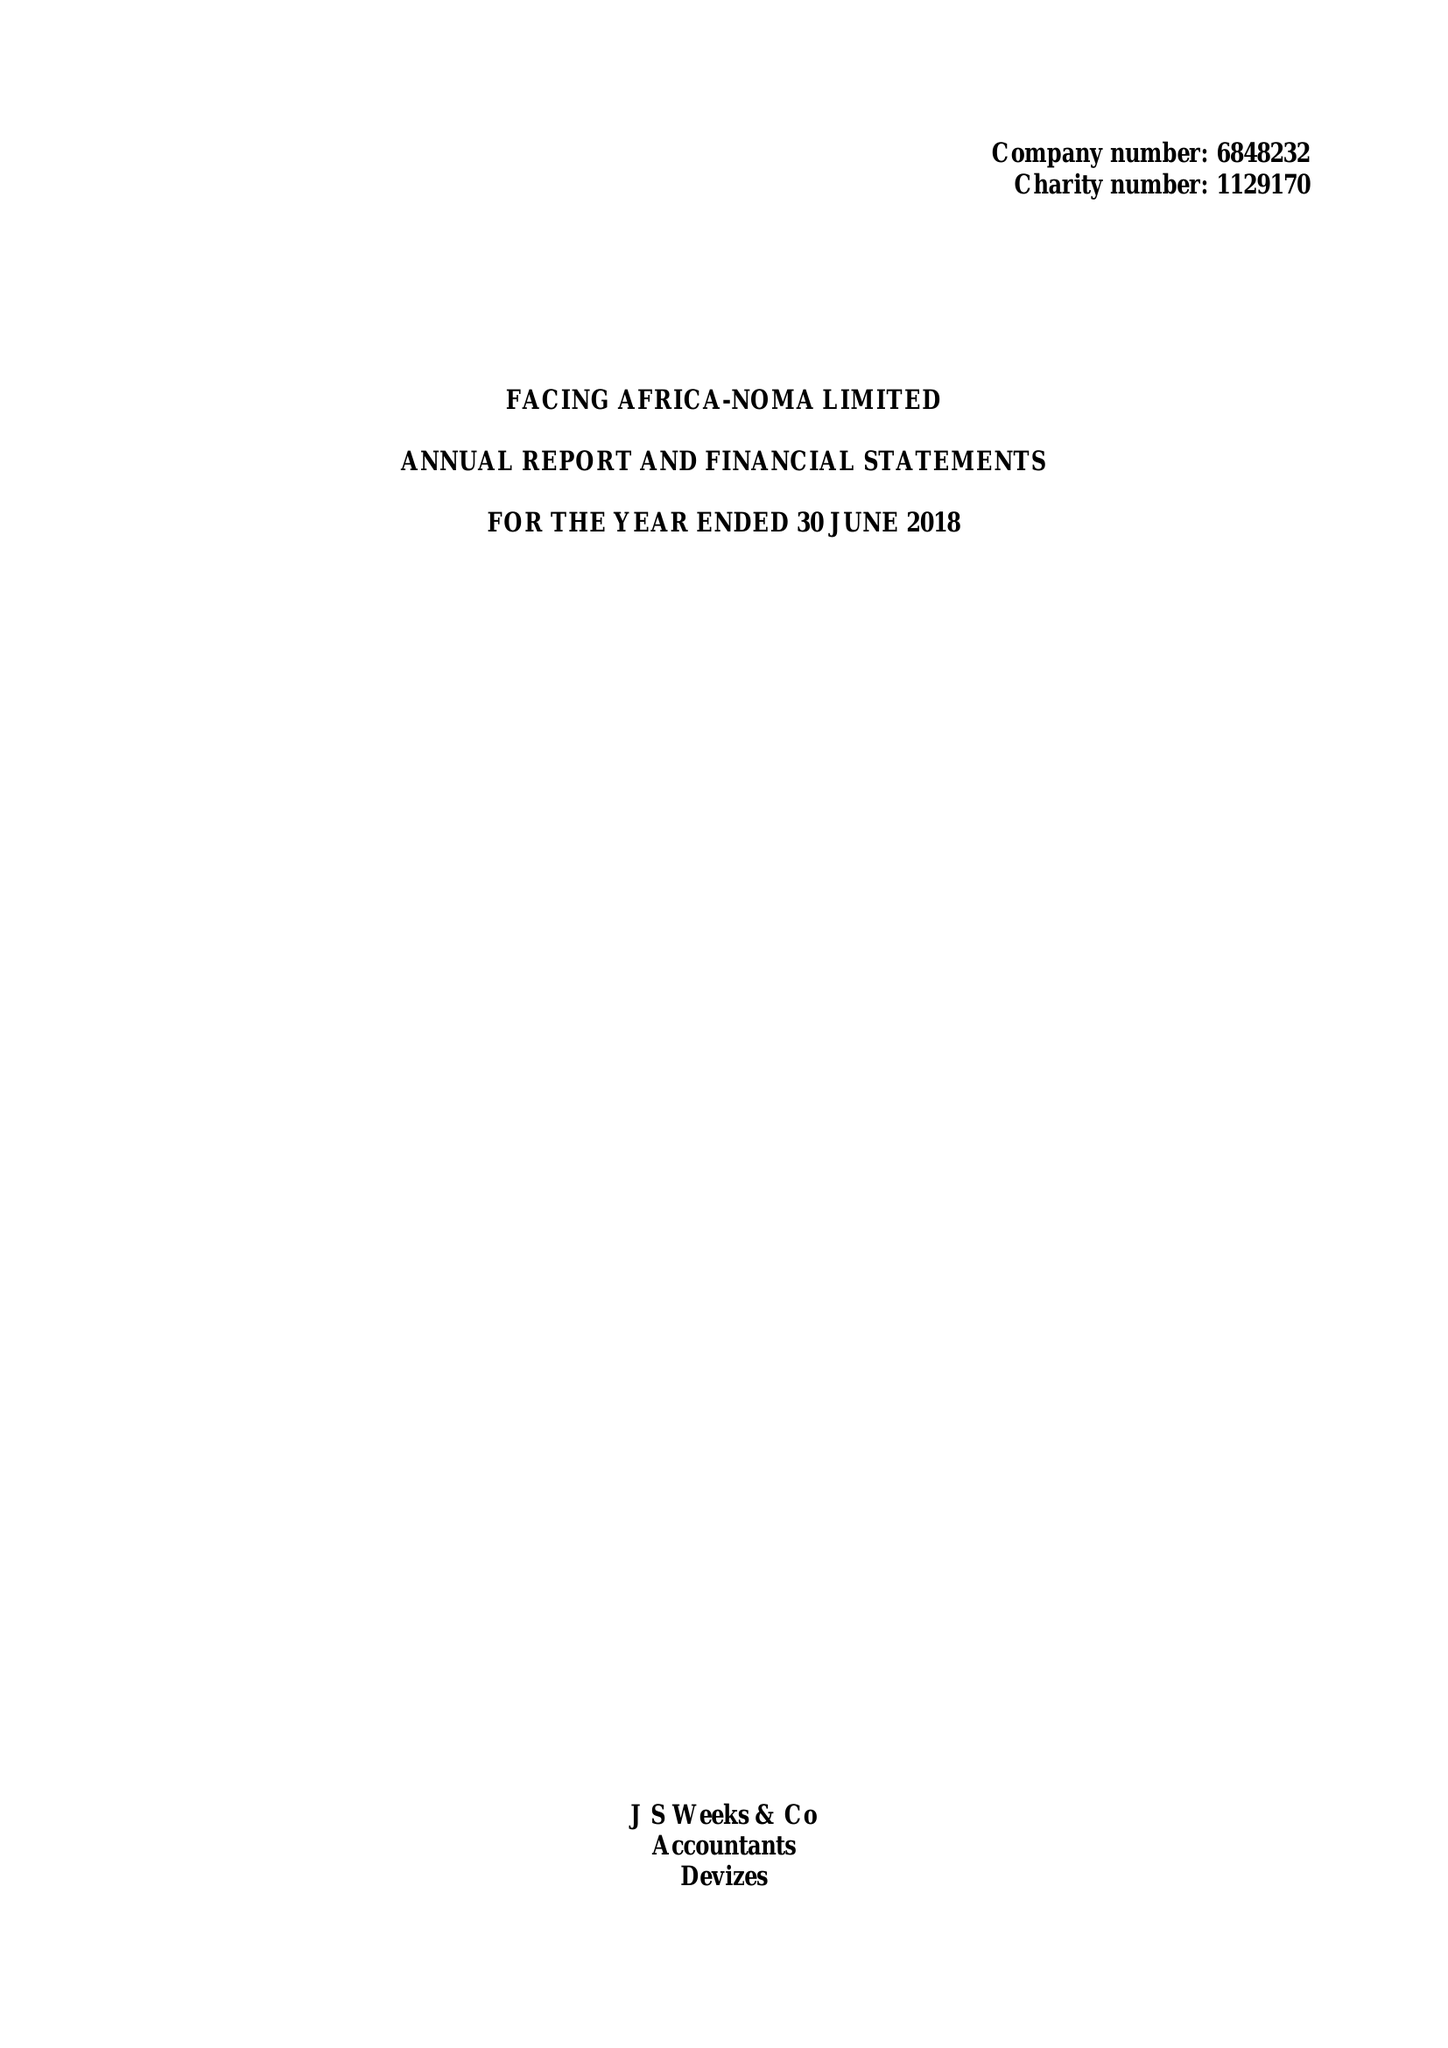What is the value for the report_date?
Answer the question using a single word or phrase. 2018-06-30 